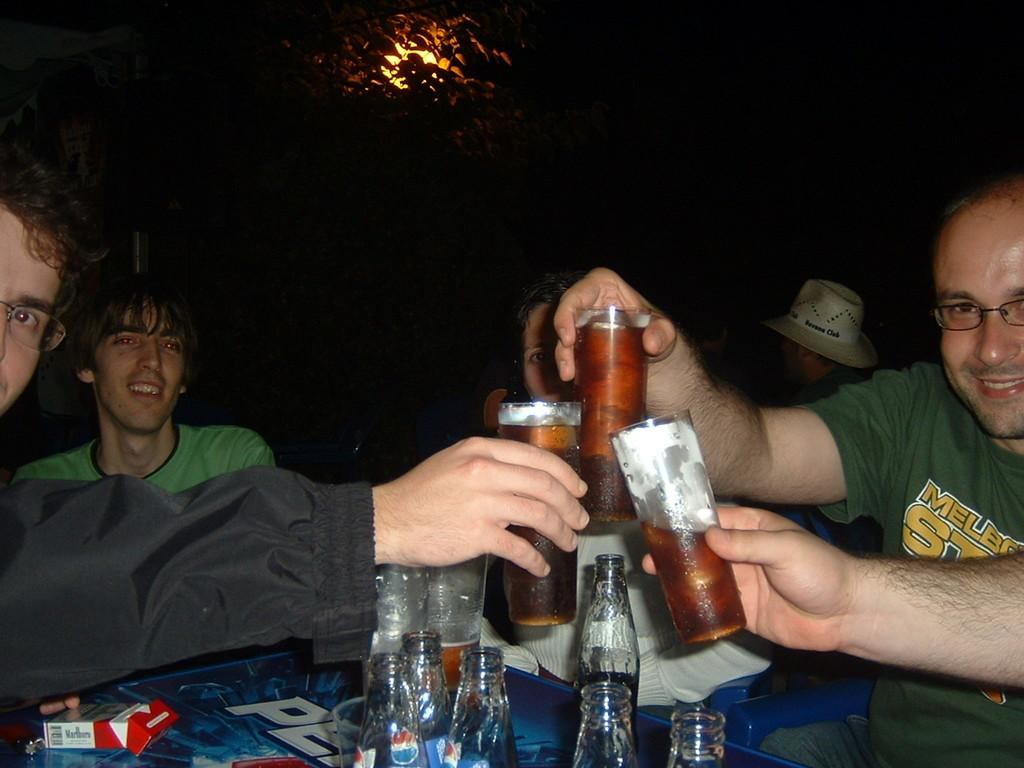<image>
Describe the image concisely. A group of friends toast their drink at a table that several Pepsi bottles and pack of Marlboro cigarettes on it. 